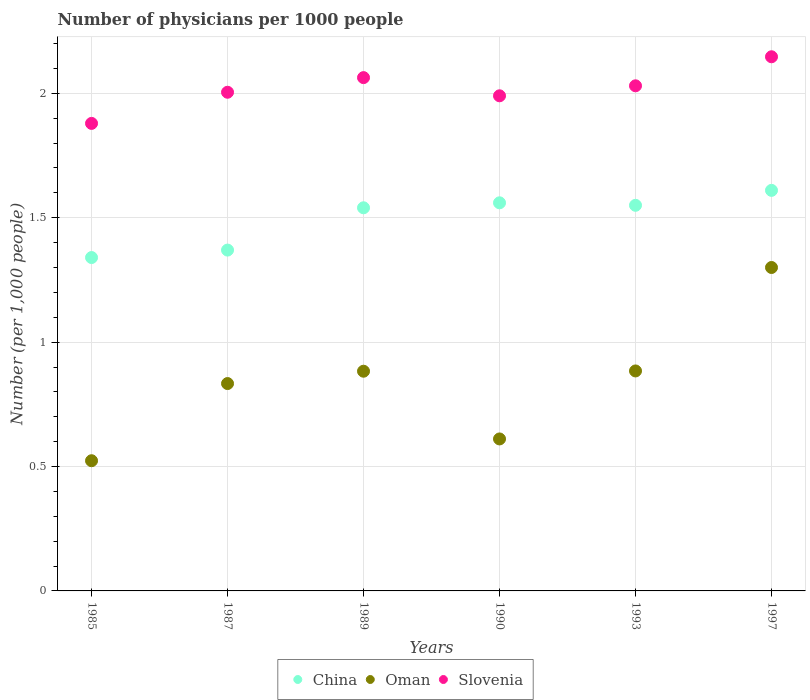Is the number of dotlines equal to the number of legend labels?
Your answer should be compact. Yes. What is the number of physicians in Slovenia in 1987?
Offer a very short reply. 2. Across all years, what is the maximum number of physicians in Slovenia?
Ensure brevity in your answer.  2.15. Across all years, what is the minimum number of physicians in China?
Offer a terse response. 1.34. In which year was the number of physicians in Oman minimum?
Offer a terse response. 1985. What is the total number of physicians in Oman in the graph?
Provide a short and direct response. 5.03. What is the difference between the number of physicians in Oman in 1993 and that in 1997?
Offer a terse response. -0.42. What is the difference between the number of physicians in China in 1985 and the number of physicians in Oman in 1990?
Your response must be concise. 0.73. What is the average number of physicians in Slovenia per year?
Ensure brevity in your answer.  2.02. In the year 1985, what is the difference between the number of physicians in Oman and number of physicians in China?
Provide a succinct answer. -0.82. In how many years, is the number of physicians in China greater than 0.30000000000000004?
Your answer should be very brief. 6. What is the ratio of the number of physicians in Slovenia in 1985 to that in 1987?
Give a very brief answer. 0.94. What is the difference between the highest and the second highest number of physicians in China?
Your answer should be very brief. 0.05. What is the difference between the highest and the lowest number of physicians in China?
Your answer should be very brief. 0.27. Is the sum of the number of physicians in China in 1987 and 1997 greater than the maximum number of physicians in Slovenia across all years?
Your response must be concise. Yes. Is it the case that in every year, the sum of the number of physicians in China and number of physicians in Oman  is greater than the number of physicians in Slovenia?
Your answer should be very brief. No. Is the number of physicians in China strictly greater than the number of physicians in Oman over the years?
Your answer should be compact. Yes. How many dotlines are there?
Offer a terse response. 3. What is the difference between two consecutive major ticks on the Y-axis?
Provide a short and direct response. 0.5. Does the graph contain grids?
Offer a terse response. Yes. What is the title of the graph?
Keep it short and to the point. Number of physicians per 1000 people. What is the label or title of the Y-axis?
Keep it short and to the point. Number (per 1,0 people). What is the Number (per 1,000 people) of China in 1985?
Your answer should be compact. 1.34. What is the Number (per 1,000 people) in Oman in 1985?
Offer a very short reply. 0.52. What is the Number (per 1,000 people) of Slovenia in 1985?
Provide a succinct answer. 1.88. What is the Number (per 1,000 people) of China in 1987?
Provide a short and direct response. 1.37. What is the Number (per 1,000 people) of Oman in 1987?
Offer a very short reply. 0.83. What is the Number (per 1,000 people) of Slovenia in 1987?
Make the answer very short. 2. What is the Number (per 1,000 people) in China in 1989?
Offer a terse response. 1.54. What is the Number (per 1,000 people) in Oman in 1989?
Make the answer very short. 0.88. What is the Number (per 1,000 people) of Slovenia in 1989?
Offer a very short reply. 2.06. What is the Number (per 1,000 people) of China in 1990?
Provide a short and direct response. 1.56. What is the Number (per 1,000 people) in Oman in 1990?
Provide a short and direct response. 0.61. What is the Number (per 1,000 people) of Slovenia in 1990?
Offer a very short reply. 1.99. What is the Number (per 1,000 people) of China in 1993?
Provide a short and direct response. 1.55. What is the Number (per 1,000 people) in Oman in 1993?
Offer a very short reply. 0.88. What is the Number (per 1,000 people) of Slovenia in 1993?
Provide a succinct answer. 2.03. What is the Number (per 1,000 people) in China in 1997?
Offer a terse response. 1.61. What is the Number (per 1,000 people) in Slovenia in 1997?
Offer a terse response. 2.15. Across all years, what is the maximum Number (per 1,000 people) in China?
Ensure brevity in your answer.  1.61. Across all years, what is the maximum Number (per 1,000 people) in Oman?
Your answer should be very brief. 1.3. Across all years, what is the maximum Number (per 1,000 people) of Slovenia?
Your answer should be very brief. 2.15. Across all years, what is the minimum Number (per 1,000 people) of China?
Your answer should be very brief. 1.34. Across all years, what is the minimum Number (per 1,000 people) of Oman?
Your response must be concise. 0.52. Across all years, what is the minimum Number (per 1,000 people) of Slovenia?
Give a very brief answer. 1.88. What is the total Number (per 1,000 people) in China in the graph?
Provide a succinct answer. 8.97. What is the total Number (per 1,000 people) in Oman in the graph?
Offer a very short reply. 5.04. What is the total Number (per 1,000 people) of Slovenia in the graph?
Keep it short and to the point. 12.11. What is the difference between the Number (per 1,000 people) in China in 1985 and that in 1987?
Your answer should be very brief. -0.03. What is the difference between the Number (per 1,000 people) in Oman in 1985 and that in 1987?
Provide a short and direct response. -0.31. What is the difference between the Number (per 1,000 people) of Slovenia in 1985 and that in 1987?
Offer a very short reply. -0.13. What is the difference between the Number (per 1,000 people) in Oman in 1985 and that in 1989?
Give a very brief answer. -0.36. What is the difference between the Number (per 1,000 people) of Slovenia in 1985 and that in 1989?
Your response must be concise. -0.18. What is the difference between the Number (per 1,000 people) of China in 1985 and that in 1990?
Give a very brief answer. -0.22. What is the difference between the Number (per 1,000 people) in Oman in 1985 and that in 1990?
Ensure brevity in your answer.  -0.09. What is the difference between the Number (per 1,000 people) of Slovenia in 1985 and that in 1990?
Provide a succinct answer. -0.11. What is the difference between the Number (per 1,000 people) of China in 1985 and that in 1993?
Provide a short and direct response. -0.21. What is the difference between the Number (per 1,000 people) of Oman in 1985 and that in 1993?
Give a very brief answer. -0.36. What is the difference between the Number (per 1,000 people) in Slovenia in 1985 and that in 1993?
Give a very brief answer. -0.15. What is the difference between the Number (per 1,000 people) in China in 1985 and that in 1997?
Give a very brief answer. -0.27. What is the difference between the Number (per 1,000 people) of Oman in 1985 and that in 1997?
Make the answer very short. -0.78. What is the difference between the Number (per 1,000 people) in Slovenia in 1985 and that in 1997?
Make the answer very short. -0.27. What is the difference between the Number (per 1,000 people) of China in 1987 and that in 1989?
Make the answer very short. -0.17. What is the difference between the Number (per 1,000 people) of Oman in 1987 and that in 1989?
Your response must be concise. -0.05. What is the difference between the Number (per 1,000 people) of Slovenia in 1987 and that in 1989?
Your answer should be compact. -0.06. What is the difference between the Number (per 1,000 people) of China in 1987 and that in 1990?
Make the answer very short. -0.19. What is the difference between the Number (per 1,000 people) of Oman in 1987 and that in 1990?
Ensure brevity in your answer.  0.22. What is the difference between the Number (per 1,000 people) in Slovenia in 1987 and that in 1990?
Ensure brevity in your answer.  0.01. What is the difference between the Number (per 1,000 people) in China in 1987 and that in 1993?
Provide a succinct answer. -0.18. What is the difference between the Number (per 1,000 people) in Oman in 1987 and that in 1993?
Offer a terse response. -0.05. What is the difference between the Number (per 1,000 people) in Slovenia in 1987 and that in 1993?
Offer a very short reply. -0.03. What is the difference between the Number (per 1,000 people) in China in 1987 and that in 1997?
Give a very brief answer. -0.24. What is the difference between the Number (per 1,000 people) of Oman in 1987 and that in 1997?
Your response must be concise. -0.47. What is the difference between the Number (per 1,000 people) in Slovenia in 1987 and that in 1997?
Your answer should be compact. -0.14. What is the difference between the Number (per 1,000 people) of China in 1989 and that in 1990?
Your answer should be compact. -0.02. What is the difference between the Number (per 1,000 people) in Oman in 1989 and that in 1990?
Keep it short and to the point. 0.27. What is the difference between the Number (per 1,000 people) in Slovenia in 1989 and that in 1990?
Your answer should be very brief. 0.07. What is the difference between the Number (per 1,000 people) in China in 1989 and that in 1993?
Make the answer very short. -0.01. What is the difference between the Number (per 1,000 people) of Oman in 1989 and that in 1993?
Your answer should be very brief. -0. What is the difference between the Number (per 1,000 people) in Slovenia in 1989 and that in 1993?
Make the answer very short. 0.03. What is the difference between the Number (per 1,000 people) in China in 1989 and that in 1997?
Keep it short and to the point. -0.07. What is the difference between the Number (per 1,000 people) of Oman in 1989 and that in 1997?
Ensure brevity in your answer.  -0.42. What is the difference between the Number (per 1,000 people) in Slovenia in 1989 and that in 1997?
Offer a terse response. -0.08. What is the difference between the Number (per 1,000 people) in China in 1990 and that in 1993?
Offer a terse response. 0.01. What is the difference between the Number (per 1,000 people) in Oman in 1990 and that in 1993?
Ensure brevity in your answer.  -0.27. What is the difference between the Number (per 1,000 people) of Slovenia in 1990 and that in 1993?
Provide a succinct answer. -0.04. What is the difference between the Number (per 1,000 people) in China in 1990 and that in 1997?
Give a very brief answer. -0.05. What is the difference between the Number (per 1,000 people) of Oman in 1990 and that in 1997?
Your answer should be compact. -0.69. What is the difference between the Number (per 1,000 people) in Slovenia in 1990 and that in 1997?
Your answer should be very brief. -0.16. What is the difference between the Number (per 1,000 people) in China in 1993 and that in 1997?
Give a very brief answer. -0.06. What is the difference between the Number (per 1,000 people) in Oman in 1993 and that in 1997?
Offer a very short reply. -0.42. What is the difference between the Number (per 1,000 people) of Slovenia in 1993 and that in 1997?
Your response must be concise. -0.12. What is the difference between the Number (per 1,000 people) of China in 1985 and the Number (per 1,000 people) of Oman in 1987?
Offer a very short reply. 0.51. What is the difference between the Number (per 1,000 people) in China in 1985 and the Number (per 1,000 people) in Slovenia in 1987?
Your answer should be very brief. -0.66. What is the difference between the Number (per 1,000 people) of Oman in 1985 and the Number (per 1,000 people) of Slovenia in 1987?
Offer a terse response. -1.48. What is the difference between the Number (per 1,000 people) of China in 1985 and the Number (per 1,000 people) of Oman in 1989?
Give a very brief answer. 0.46. What is the difference between the Number (per 1,000 people) of China in 1985 and the Number (per 1,000 people) of Slovenia in 1989?
Provide a succinct answer. -0.72. What is the difference between the Number (per 1,000 people) in Oman in 1985 and the Number (per 1,000 people) in Slovenia in 1989?
Offer a terse response. -1.54. What is the difference between the Number (per 1,000 people) of China in 1985 and the Number (per 1,000 people) of Oman in 1990?
Your answer should be very brief. 0.73. What is the difference between the Number (per 1,000 people) in China in 1985 and the Number (per 1,000 people) in Slovenia in 1990?
Your response must be concise. -0.65. What is the difference between the Number (per 1,000 people) of Oman in 1985 and the Number (per 1,000 people) of Slovenia in 1990?
Your answer should be compact. -1.47. What is the difference between the Number (per 1,000 people) in China in 1985 and the Number (per 1,000 people) in Oman in 1993?
Your response must be concise. 0.46. What is the difference between the Number (per 1,000 people) of China in 1985 and the Number (per 1,000 people) of Slovenia in 1993?
Ensure brevity in your answer.  -0.69. What is the difference between the Number (per 1,000 people) in Oman in 1985 and the Number (per 1,000 people) in Slovenia in 1993?
Provide a short and direct response. -1.51. What is the difference between the Number (per 1,000 people) in China in 1985 and the Number (per 1,000 people) in Oman in 1997?
Make the answer very short. 0.04. What is the difference between the Number (per 1,000 people) of China in 1985 and the Number (per 1,000 people) of Slovenia in 1997?
Provide a succinct answer. -0.81. What is the difference between the Number (per 1,000 people) in Oman in 1985 and the Number (per 1,000 people) in Slovenia in 1997?
Ensure brevity in your answer.  -1.62. What is the difference between the Number (per 1,000 people) of China in 1987 and the Number (per 1,000 people) of Oman in 1989?
Provide a short and direct response. 0.49. What is the difference between the Number (per 1,000 people) of China in 1987 and the Number (per 1,000 people) of Slovenia in 1989?
Your answer should be compact. -0.69. What is the difference between the Number (per 1,000 people) of Oman in 1987 and the Number (per 1,000 people) of Slovenia in 1989?
Offer a very short reply. -1.23. What is the difference between the Number (per 1,000 people) of China in 1987 and the Number (per 1,000 people) of Oman in 1990?
Ensure brevity in your answer.  0.76. What is the difference between the Number (per 1,000 people) in China in 1987 and the Number (per 1,000 people) in Slovenia in 1990?
Offer a very short reply. -0.62. What is the difference between the Number (per 1,000 people) of Oman in 1987 and the Number (per 1,000 people) of Slovenia in 1990?
Give a very brief answer. -1.16. What is the difference between the Number (per 1,000 people) in China in 1987 and the Number (per 1,000 people) in Oman in 1993?
Offer a terse response. 0.49. What is the difference between the Number (per 1,000 people) of China in 1987 and the Number (per 1,000 people) of Slovenia in 1993?
Give a very brief answer. -0.66. What is the difference between the Number (per 1,000 people) of Oman in 1987 and the Number (per 1,000 people) of Slovenia in 1993?
Ensure brevity in your answer.  -1.2. What is the difference between the Number (per 1,000 people) in China in 1987 and the Number (per 1,000 people) in Oman in 1997?
Offer a very short reply. 0.07. What is the difference between the Number (per 1,000 people) in China in 1987 and the Number (per 1,000 people) in Slovenia in 1997?
Provide a succinct answer. -0.78. What is the difference between the Number (per 1,000 people) in Oman in 1987 and the Number (per 1,000 people) in Slovenia in 1997?
Your answer should be compact. -1.31. What is the difference between the Number (per 1,000 people) of China in 1989 and the Number (per 1,000 people) of Oman in 1990?
Your answer should be compact. 0.93. What is the difference between the Number (per 1,000 people) of China in 1989 and the Number (per 1,000 people) of Slovenia in 1990?
Offer a very short reply. -0.45. What is the difference between the Number (per 1,000 people) in Oman in 1989 and the Number (per 1,000 people) in Slovenia in 1990?
Offer a terse response. -1.11. What is the difference between the Number (per 1,000 people) of China in 1989 and the Number (per 1,000 people) of Oman in 1993?
Ensure brevity in your answer.  0.66. What is the difference between the Number (per 1,000 people) of China in 1989 and the Number (per 1,000 people) of Slovenia in 1993?
Keep it short and to the point. -0.49. What is the difference between the Number (per 1,000 people) of Oman in 1989 and the Number (per 1,000 people) of Slovenia in 1993?
Keep it short and to the point. -1.15. What is the difference between the Number (per 1,000 people) in China in 1989 and the Number (per 1,000 people) in Oman in 1997?
Your answer should be very brief. 0.24. What is the difference between the Number (per 1,000 people) in China in 1989 and the Number (per 1,000 people) in Slovenia in 1997?
Ensure brevity in your answer.  -0.61. What is the difference between the Number (per 1,000 people) of Oman in 1989 and the Number (per 1,000 people) of Slovenia in 1997?
Your response must be concise. -1.26. What is the difference between the Number (per 1,000 people) in China in 1990 and the Number (per 1,000 people) in Oman in 1993?
Ensure brevity in your answer.  0.68. What is the difference between the Number (per 1,000 people) of China in 1990 and the Number (per 1,000 people) of Slovenia in 1993?
Provide a succinct answer. -0.47. What is the difference between the Number (per 1,000 people) of Oman in 1990 and the Number (per 1,000 people) of Slovenia in 1993?
Provide a succinct answer. -1.42. What is the difference between the Number (per 1,000 people) of China in 1990 and the Number (per 1,000 people) of Oman in 1997?
Provide a short and direct response. 0.26. What is the difference between the Number (per 1,000 people) in China in 1990 and the Number (per 1,000 people) in Slovenia in 1997?
Provide a succinct answer. -0.59. What is the difference between the Number (per 1,000 people) in Oman in 1990 and the Number (per 1,000 people) in Slovenia in 1997?
Keep it short and to the point. -1.54. What is the difference between the Number (per 1,000 people) in China in 1993 and the Number (per 1,000 people) in Slovenia in 1997?
Give a very brief answer. -0.6. What is the difference between the Number (per 1,000 people) of Oman in 1993 and the Number (per 1,000 people) of Slovenia in 1997?
Your answer should be compact. -1.26. What is the average Number (per 1,000 people) of China per year?
Offer a very short reply. 1.5. What is the average Number (per 1,000 people) of Oman per year?
Keep it short and to the point. 0.84. What is the average Number (per 1,000 people) in Slovenia per year?
Offer a terse response. 2.02. In the year 1985, what is the difference between the Number (per 1,000 people) of China and Number (per 1,000 people) of Oman?
Your response must be concise. 0.82. In the year 1985, what is the difference between the Number (per 1,000 people) of China and Number (per 1,000 people) of Slovenia?
Your response must be concise. -0.54. In the year 1985, what is the difference between the Number (per 1,000 people) in Oman and Number (per 1,000 people) in Slovenia?
Your answer should be compact. -1.36. In the year 1987, what is the difference between the Number (per 1,000 people) of China and Number (per 1,000 people) of Oman?
Your answer should be very brief. 0.54. In the year 1987, what is the difference between the Number (per 1,000 people) in China and Number (per 1,000 people) in Slovenia?
Keep it short and to the point. -0.63. In the year 1987, what is the difference between the Number (per 1,000 people) in Oman and Number (per 1,000 people) in Slovenia?
Offer a very short reply. -1.17. In the year 1989, what is the difference between the Number (per 1,000 people) in China and Number (per 1,000 people) in Oman?
Your answer should be very brief. 0.66. In the year 1989, what is the difference between the Number (per 1,000 people) in China and Number (per 1,000 people) in Slovenia?
Give a very brief answer. -0.52. In the year 1989, what is the difference between the Number (per 1,000 people) in Oman and Number (per 1,000 people) in Slovenia?
Ensure brevity in your answer.  -1.18. In the year 1990, what is the difference between the Number (per 1,000 people) in China and Number (per 1,000 people) in Oman?
Your answer should be compact. 0.95. In the year 1990, what is the difference between the Number (per 1,000 people) in China and Number (per 1,000 people) in Slovenia?
Provide a short and direct response. -0.43. In the year 1990, what is the difference between the Number (per 1,000 people) of Oman and Number (per 1,000 people) of Slovenia?
Your answer should be compact. -1.38. In the year 1993, what is the difference between the Number (per 1,000 people) of China and Number (per 1,000 people) of Oman?
Provide a succinct answer. 0.67. In the year 1993, what is the difference between the Number (per 1,000 people) of China and Number (per 1,000 people) of Slovenia?
Your answer should be very brief. -0.48. In the year 1993, what is the difference between the Number (per 1,000 people) in Oman and Number (per 1,000 people) in Slovenia?
Provide a succinct answer. -1.15. In the year 1997, what is the difference between the Number (per 1,000 people) in China and Number (per 1,000 people) in Oman?
Offer a terse response. 0.31. In the year 1997, what is the difference between the Number (per 1,000 people) in China and Number (per 1,000 people) in Slovenia?
Your response must be concise. -0.54. In the year 1997, what is the difference between the Number (per 1,000 people) in Oman and Number (per 1,000 people) in Slovenia?
Keep it short and to the point. -0.85. What is the ratio of the Number (per 1,000 people) in China in 1985 to that in 1987?
Your answer should be compact. 0.98. What is the ratio of the Number (per 1,000 people) of Oman in 1985 to that in 1987?
Give a very brief answer. 0.63. What is the ratio of the Number (per 1,000 people) of China in 1985 to that in 1989?
Provide a short and direct response. 0.87. What is the ratio of the Number (per 1,000 people) of Oman in 1985 to that in 1989?
Your response must be concise. 0.59. What is the ratio of the Number (per 1,000 people) of Slovenia in 1985 to that in 1989?
Make the answer very short. 0.91. What is the ratio of the Number (per 1,000 people) of China in 1985 to that in 1990?
Keep it short and to the point. 0.86. What is the ratio of the Number (per 1,000 people) of Oman in 1985 to that in 1990?
Give a very brief answer. 0.86. What is the ratio of the Number (per 1,000 people) in Slovenia in 1985 to that in 1990?
Provide a succinct answer. 0.94. What is the ratio of the Number (per 1,000 people) of China in 1985 to that in 1993?
Give a very brief answer. 0.86. What is the ratio of the Number (per 1,000 people) in Oman in 1985 to that in 1993?
Offer a very short reply. 0.59. What is the ratio of the Number (per 1,000 people) in Slovenia in 1985 to that in 1993?
Ensure brevity in your answer.  0.93. What is the ratio of the Number (per 1,000 people) in China in 1985 to that in 1997?
Provide a short and direct response. 0.83. What is the ratio of the Number (per 1,000 people) of Oman in 1985 to that in 1997?
Ensure brevity in your answer.  0.4. What is the ratio of the Number (per 1,000 people) of Slovenia in 1985 to that in 1997?
Offer a very short reply. 0.88. What is the ratio of the Number (per 1,000 people) in China in 1987 to that in 1989?
Make the answer very short. 0.89. What is the ratio of the Number (per 1,000 people) of Oman in 1987 to that in 1989?
Keep it short and to the point. 0.94. What is the ratio of the Number (per 1,000 people) of Slovenia in 1987 to that in 1989?
Offer a terse response. 0.97. What is the ratio of the Number (per 1,000 people) in China in 1987 to that in 1990?
Provide a succinct answer. 0.88. What is the ratio of the Number (per 1,000 people) of Oman in 1987 to that in 1990?
Offer a very short reply. 1.36. What is the ratio of the Number (per 1,000 people) in China in 1987 to that in 1993?
Ensure brevity in your answer.  0.88. What is the ratio of the Number (per 1,000 people) in Oman in 1987 to that in 1993?
Provide a short and direct response. 0.94. What is the ratio of the Number (per 1,000 people) in Slovenia in 1987 to that in 1993?
Your response must be concise. 0.99. What is the ratio of the Number (per 1,000 people) in China in 1987 to that in 1997?
Your answer should be compact. 0.85. What is the ratio of the Number (per 1,000 people) in Oman in 1987 to that in 1997?
Your answer should be compact. 0.64. What is the ratio of the Number (per 1,000 people) of Slovenia in 1987 to that in 1997?
Provide a succinct answer. 0.93. What is the ratio of the Number (per 1,000 people) of China in 1989 to that in 1990?
Your response must be concise. 0.99. What is the ratio of the Number (per 1,000 people) of Oman in 1989 to that in 1990?
Offer a terse response. 1.45. What is the ratio of the Number (per 1,000 people) of Slovenia in 1989 to that in 1990?
Your answer should be very brief. 1.04. What is the ratio of the Number (per 1,000 people) of Slovenia in 1989 to that in 1993?
Offer a very short reply. 1.02. What is the ratio of the Number (per 1,000 people) of China in 1989 to that in 1997?
Provide a succinct answer. 0.96. What is the ratio of the Number (per 1,000 people) in Oman in 1989 to that in 1997?
Your answer should be very brief. 0.68. What is the ratio of the Number (per 1,000 people) in Slovenia in 1989 to that in 1997?
Provide a succinct answer. 0.96. What is the ratio of the Number (per 1,000 people) of China in 1990 to that in 1993?
Keep it short and to the point. 1.01. What is the ratio of the Number (per 1,000 people) of Oman in 1990 to that in 1993?
Give a very brief answer. 0.69. What is the ratio of the Number (per 1,000 people) in Slovenia in 1990 to that in 1993?
Your answer should be very brief. 0.98. What is the ratio of the Number (per 1,000 people) of China in 1990 to that in 1997?
Your response must be concise. 0.97. What is the ratio of the Number (per 1,000 people) of Oman in 1990 to that in 1997?
Make the answer very short. 0.47. What is the ratio of the Number (per 1,000 people) in Slovenia in 1990 to that in 1997?
Offer a very short reply. 0.93. What is the ratio of the Number (per 1,000 people) in China in 1993 to that in 1997?
Your answer should be compact. 0.96. What is the ratio of the Number (per 1,000 people) in Oman in 1993 to that in 1997?
Provide a succinct answer. 0.68. What is the ratio of the Number (per 1,000 people) in Slovenia in 1993 to that in 1997?
Provide a succinct answer. 0.95. What is the difference between the highest and the second highest Number (per 1,000 people) in China?
Offer a very short reply. 0.05. What is the difference between the highest and the second highest Number (per 1,000 people) in Oman?
Your response must be concise. 0.42. What is the difference between the highest and the second highest Number (per 1,000 people) of Slovenia?
Provide a succinct answer. 0.08. What is the difference between the highest and the lowest Number (per 1,000 people) of China?
Offer a very short reply. 0.27. What is the difference between the highest and the lowest Number (per 1,000 people) in Oman?
Keep it short and to the point. 0.78. What is the difference between the highest and the lowest Number (per 1,000 people) of Slovenia?
Offer a terse response. 0.27. 